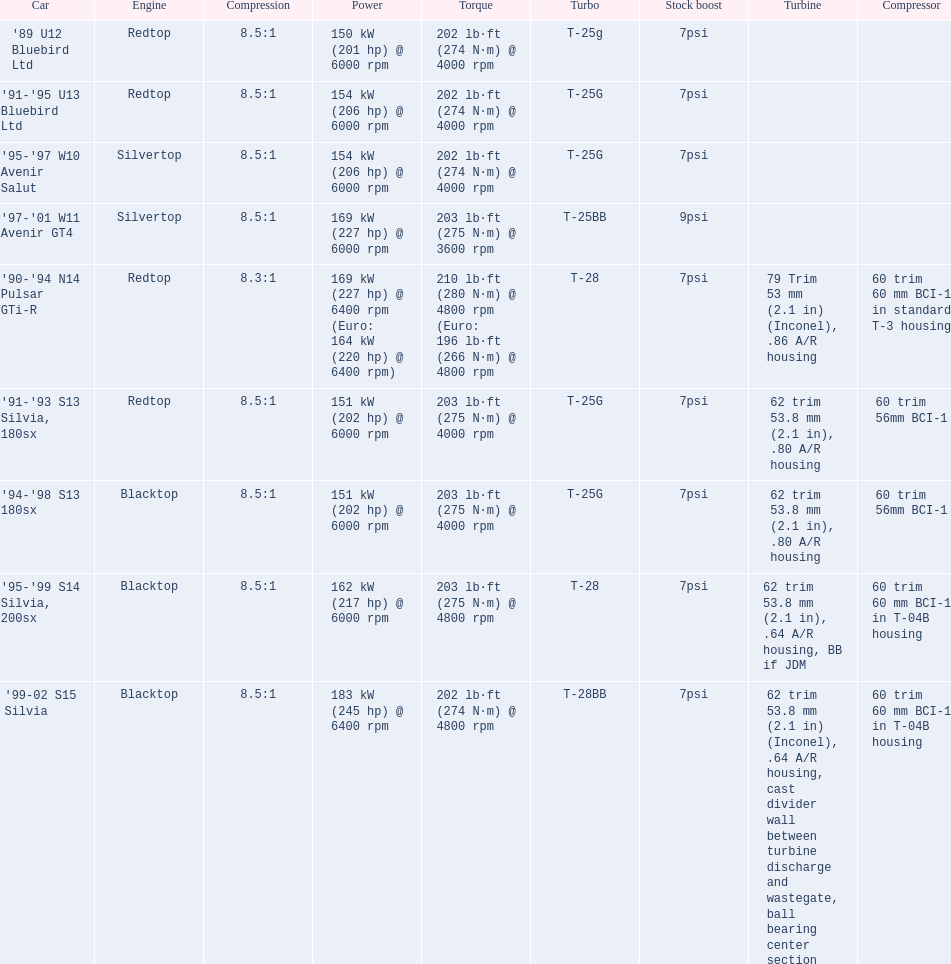What are the cars' specified horsepower values? 150 kW (201 hp) @ 6000 rpm, 154 kW (206 hp) @ 6000 rpm, 154 kW (206 hp) @ 6000 rpm, 169 kW (227 hp) @ 6000 rpm, 169 kW (227 hp) @ 6400 rpm (Euro: 164 kW (220 hp) @ 6400 rpm), 151 kW (202 hp) @ 6000 rpm, 151 kW (202 hp) @ 6000 rpm, 162 kW (217 hp) @ 6000 rpm, 183 kW (245 hp) @ 6400 rpm. Which car exclusively possesses more than 230 hp? '99-02 S15 Silvia. Would you be able to parse every entry in this table? {'header': ['Car', 'Engine', 'Compression', 'Power', 'Torque', 'Turbo', 'Stock boost', 'Turbine', 'Compressor'], 'rows': [["'89 U12 Bluebird Ltd", 'Redtop', '8.5:1', '150\xa0kW (201\xa0hp) @ 6000 rpm', '202\xa0lb·ft (274\xa0N·m) @ 4000 rpm', 'T-25g', '7psi', '', ''], ["'91-'95 U13 Bluebird Ltd", 'Redtop', '8.5:1', '154\xa0kW (206\xa0hp) @ 6000 rpm', '202\xa0lb·ft (274\xa0N·m) @ 4000 rpm', 'T-25G', '7psi', '', ''], ["'95-'97 W10 Avenir Salut", 'Silvertop', '8.5:1', '154\xa0kW (206\xa0hp) @ 6000 rpm', '202\xa0lb·ft (274\xa0N·m) @ 4000 rpm', 'T-25G', '7psi', '', ''], ["'97-'01 W11 Avenir GT4", 'Silvertop', '8.5:1', '169\xa0kW (227\xa0hp) @ 6000 rpm', '203\xa0lb·ft (275\xa0N·m) @ 3600 rpm', 'T-25BB', '9psi', '', ''], ["'90-'94 N14 Pulsar GTi-R", 'Redtop', '8.3:1', '169\xa0kW (227\xa0hp) @ 6400 rpm (Euro: 164\xa0kW (220\xa0hp) @ 6400 rpm)', '210\xa0lb·ft (280\xa0N·m) @ 4800 rpm (Euro: 196\xa0lb·ft (266\xa0N·m) @ 4800 rpm', 'T-28', '7psi', '79 Trim 53\xa0mm (2.1\xa0in) (Inconel), .86 A/R housing', '60 trim 60\xa0mm BCI-1 in standard T-3 housing'], ["'91-'93 S13 Silvia, 180sx", 'Redtop', '8.5:1', '151\xa0kW (202\xa0hp) @ 6000 rpm', '203\xa0lb·ft (275\xa0N·m) @ 4000 rpm', 'T-25G', '7psi', '62 trim 53.8\xa0mm (2.1\xa0in), .80 A/R housing', '60 trim 56mm BCI-1'], ["'94-'98 S13 180sx", 'Blacktop', '8.5:1', '151\xa0kW (202\xa0hp) @ 6000 rpm', '203\xa0lb·ft (275\xa0N·m) @ 4000 rpm', 'T-25G', '7psi', '62 trim 53.8\xa0mm (2.1\xa0in), .80 A/R housing', '60 trim 56mm BCI-1'], ["'95-'99 S14 Silvia, 200sx", 'Blacktop', '8.5:1', '162\xa0kW (217\xa0hp) @ 6000 rpm', '203\xa0lb·ft (275\xa0N·m) @ 4800 rpm', 'T-28', '7psi', '62 trim 53.8\xa0mm (2.1\xa0in), .64 A/R housing, BB if JDM', '60 trim 60\xa0mm BCI-1 in T-04B housing'], ["'99-02 S15 Silvia", 'Blacktop', '8.5:1', '183\xa0kW (245\xa0hp) @ 6400 rpm', '202\xa0lb·ft (274\xa0N·m) @ 4800 rpm', 'T-28BB', '7psi', '62 trim 53.8\xa0mm (2.1\xa0in) (Inconel), .64 A/R housing, cast divider wall between turbine discharge and wastegate, ball bearing center section', '60 trim 60\xa0mm BCI-1 in T-04B housing']]} 